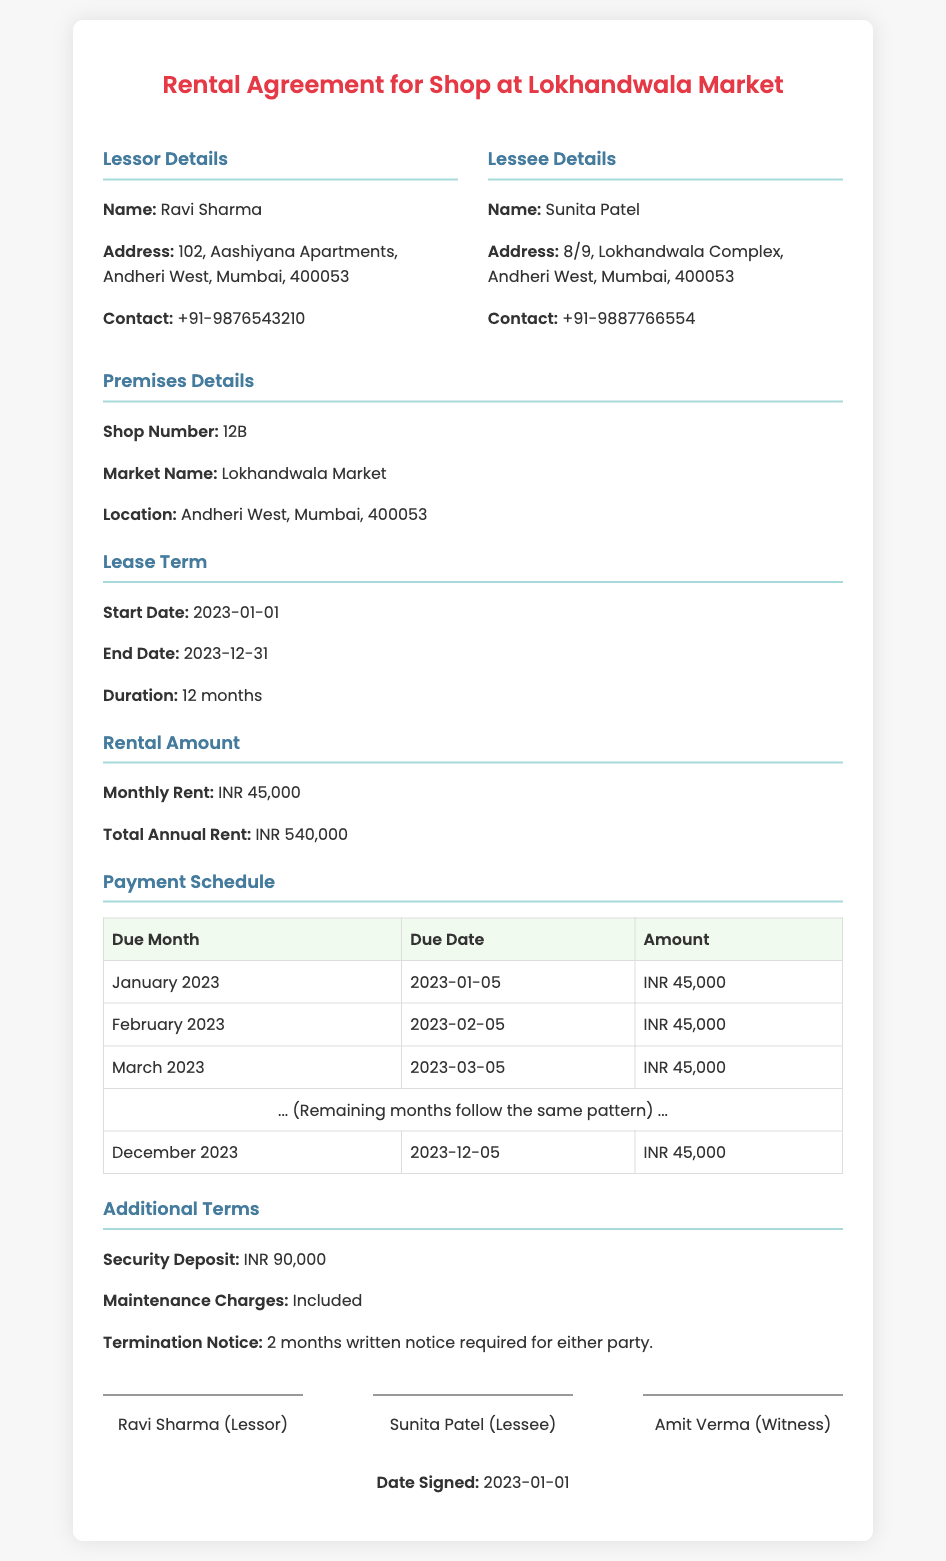What is the monthly rent? The monthly rent is specified in the document under the Rental Amount section.
Answer: INR 45,000 What is the total annual rent? The total annual rent is calculated as the monthly rent multiplied by 12 months.
Answer: INR 540,000 When is the payment due for February 2023? The due date for February 2023 is mentioned in the Payment Schedule table.
Answer: 2023-02-05 What is the security deposit amount? The security deposit is listed in the Additional Terms section of the document.
Answer: INR 90,000 Who is the lessor? The lessor's name is provided in the Lessor Details section.
Answer: Ravi Sharma How long is the lease term? The lease term's duration is explicitly stated in the Lease Term section.
Answer: 12 months What are the maintenance charges? The maintenance charges are noted in the Additional Terms section.
Answer: Included What is required for termination notice? The requirements for termination notice are specified in the Additional Terms section.
Answer: 2 months written notice What is the shop number? The shop number is indicated in the Premises Details section.
Answer: 12B 